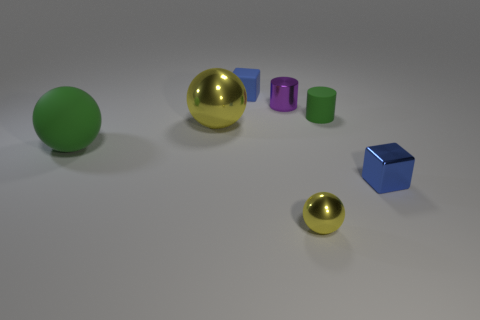Can you describe the difference between the surfaces of the gold and green spheres? Certainly! The gold sphere has a highly reflective, shiny surface, indicating it is likely a polished metal or metallic paint finish. In contrast, the green sphere has a matte, uniform surface, suggestive of a plastic or painted material lacking reflectiveness. 